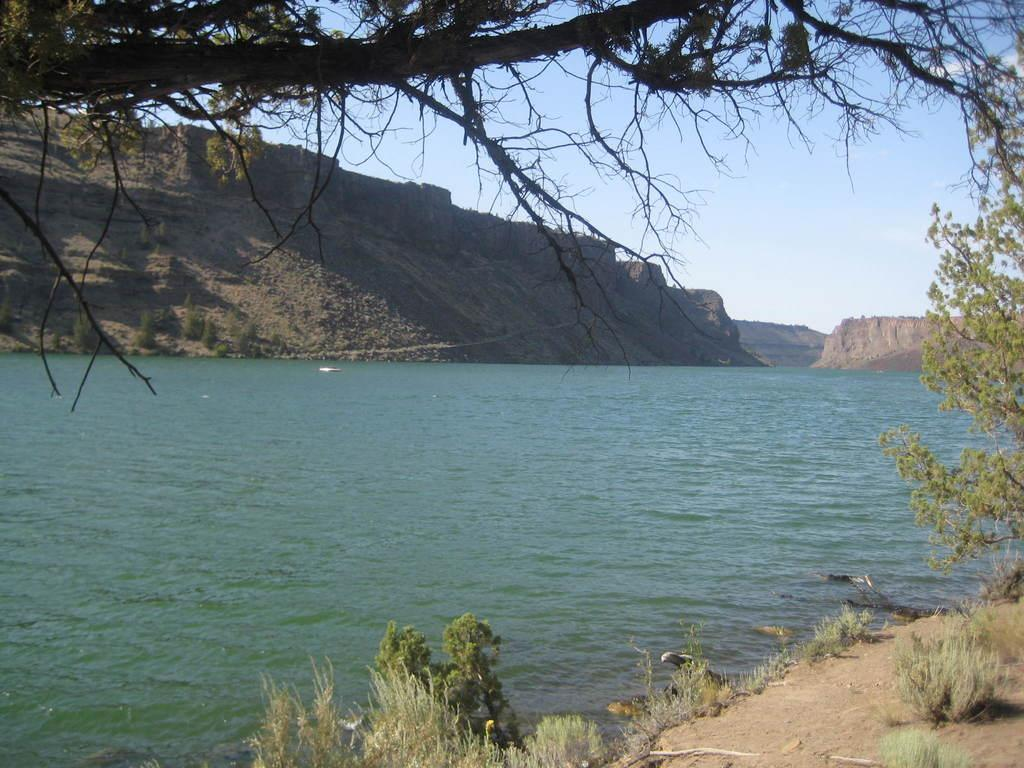What types of vegetation can be seen in the foreground of the picture? There are trees and shrubs in the foreground of the picture. What type of terrain is visible in the foreground of the picture? There is soil in the foreground of the picture. What is the main feature in the center of the picture? There is a water body in the center of the picture. What type of landscape can be seen in the background of the picture? There are mountains in the background of the picture. What is the weather like in the image? The sky is sunny in the image. Can you see any roses growing near the water body in the image? There are no roses visible in the image; the foreground features trees, shrubs, and soil. Is there an airport visible in the background of the image? There is no airport present in the image; the background features mountains. 